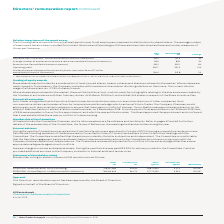According to Auto Trader's financial document, What does the table in the context show? the Group’s actual spend on pay for all employees compared to distributions to shareholders. The document states: "nce of the spend on pay The following table shows the Group’s actual spend on pay for all employees compared to distributions to shareholders. The ave..." Also, Why has the 2018 figures in the table been restated? to reflect the adoption of IFRS 9, IFRS 15 and IFRS 16, and to include share buybacks. The document states: "1 2018 comparatives have been restated to reflect the adoption of IFRS 9, IFRS 15 and IFRS 16, and to include share buybacks...." Also, Which items in the table are key measures of Group performance? The document shows two values: Revenue and Operating profit. From the document: "s has also been included for context. Revenue and Operating profit have also been disclosed as these are two key measures of Group performance. of emp..." Additionally, In which year were employee costs larger? According to the financial document, 2019. The relevant text states: "2019 £m Restated 2018 £m % change..." Also, can you calculate: What was the change in employee costs in 2019 from 2018? Based on the calculation: 56.0-54.5, the result is 1.5 (in millions). This is based on the information: "7 to the consolidated financial statements) 56.0 54.5 3% note 7 to the consolidated financial statements) 56.0 54.5 3%..." The key data points involved are: 54.5, 56.0. Also, can you calculate: What was the average operating profit in 2018 and 2019? To answer this question, I need to perform calculations using the financial data. The calculation is: (243.7+221.3)/2, which equals 232.5 (in millions). This is based on the information: "Operating profit 243.7 221.3 10% Operating profit 243.7 221.3 10%..." The key data points involved are: 221.3, 243.7. 